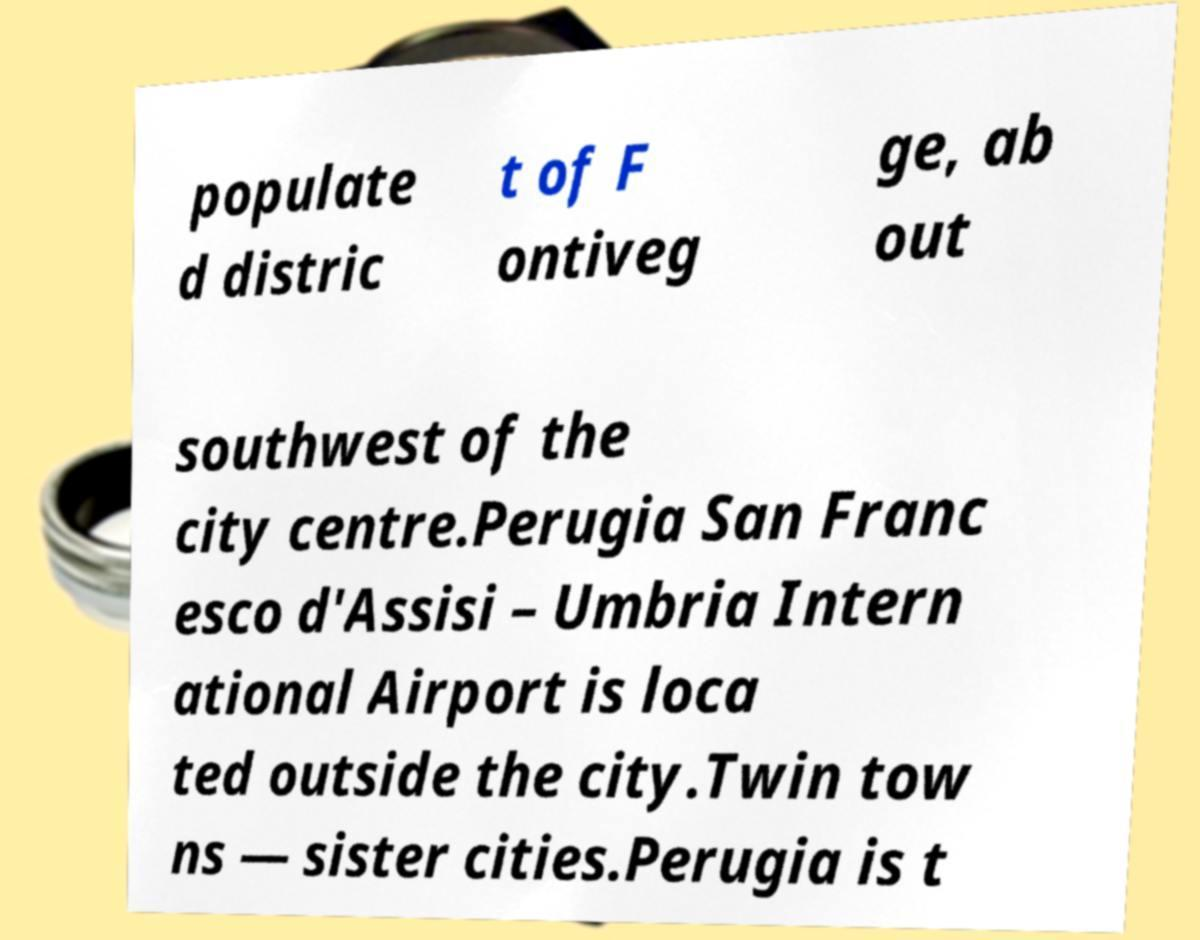I need the written content from this picture converted into text. Can you do that? populate d distric t of F ontiveg ge, ab out southwest of the city centre.Perugia San Franc esco d'Assisi – Umbria Intern ational Airport is loca ted outside the city.Twin tow ns — sister cities.Perugia is t 